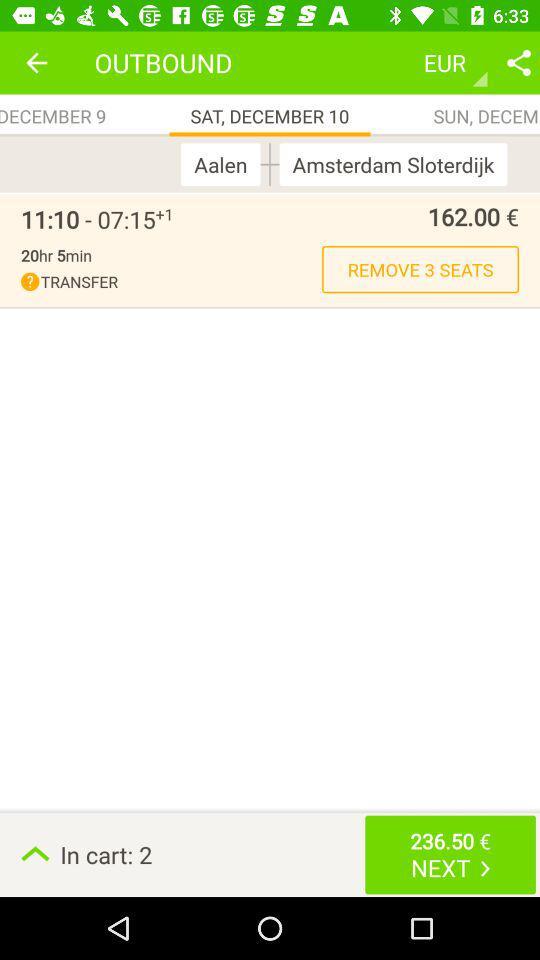What is the total journey time? The total journey time is 20 hours 5 minutes. 